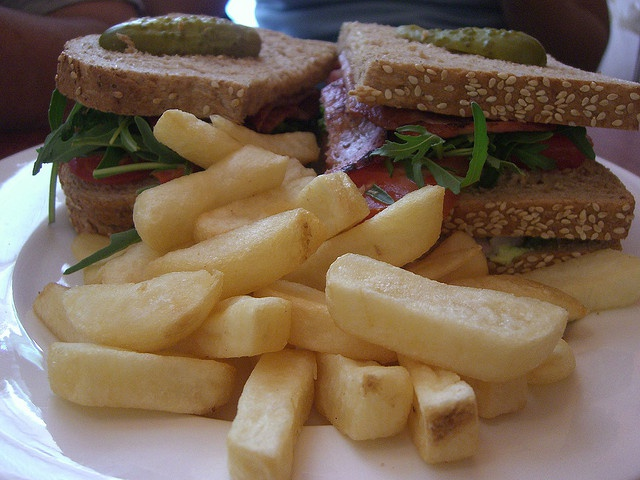Describe the objects in this image and their specific colors. I can see apple in black, olive, tan, and darkgray tones, sandwich in black, maroon, and gray tones, sandwich in black, maroon, and gray tones, people in black and gray tones, and banana in black, olive, and tan tones in this image. 